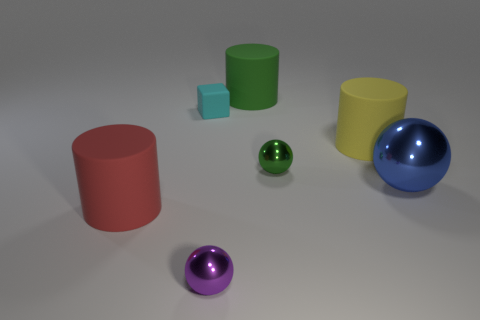Is there anything else that is the same shape as the cyan thing?
Make the answer very short. No. Is the tiny green metallic thing the same shape as the big blue thing?
Your answer should be compact. Yes. How many balls are either large metal objects or tiny metallic things?
Your response must be concise. 3. What is the color of the other small sphere that is made of the same material as the tiny purple ball?
Your answer should be compact. Green. There is a thing in front of the red thing; does it have the same size as the cyan rubber block?
Provide a short and direct response. Yes. Is the material of the blue object the same as the big cylinder that is to the left of the green cylinder?
Keep it short and to the point. No. The big object that is behind the tiny cyan rubber block is what color?
Offer a terse response. Green. Are there any green balls on the left side of the large rubber cylinder right of the green rubber thing?
Offer a very short reply. Yes. There is a rubber cylinder behind the cyan cube; does it have the same color as the tiny metallic object behind the big red object?
Provide a succinct answer. Yes. There is a large green thing; how many tiny cyan cubes are in front of it?
Your answer should be very brief. 1. 